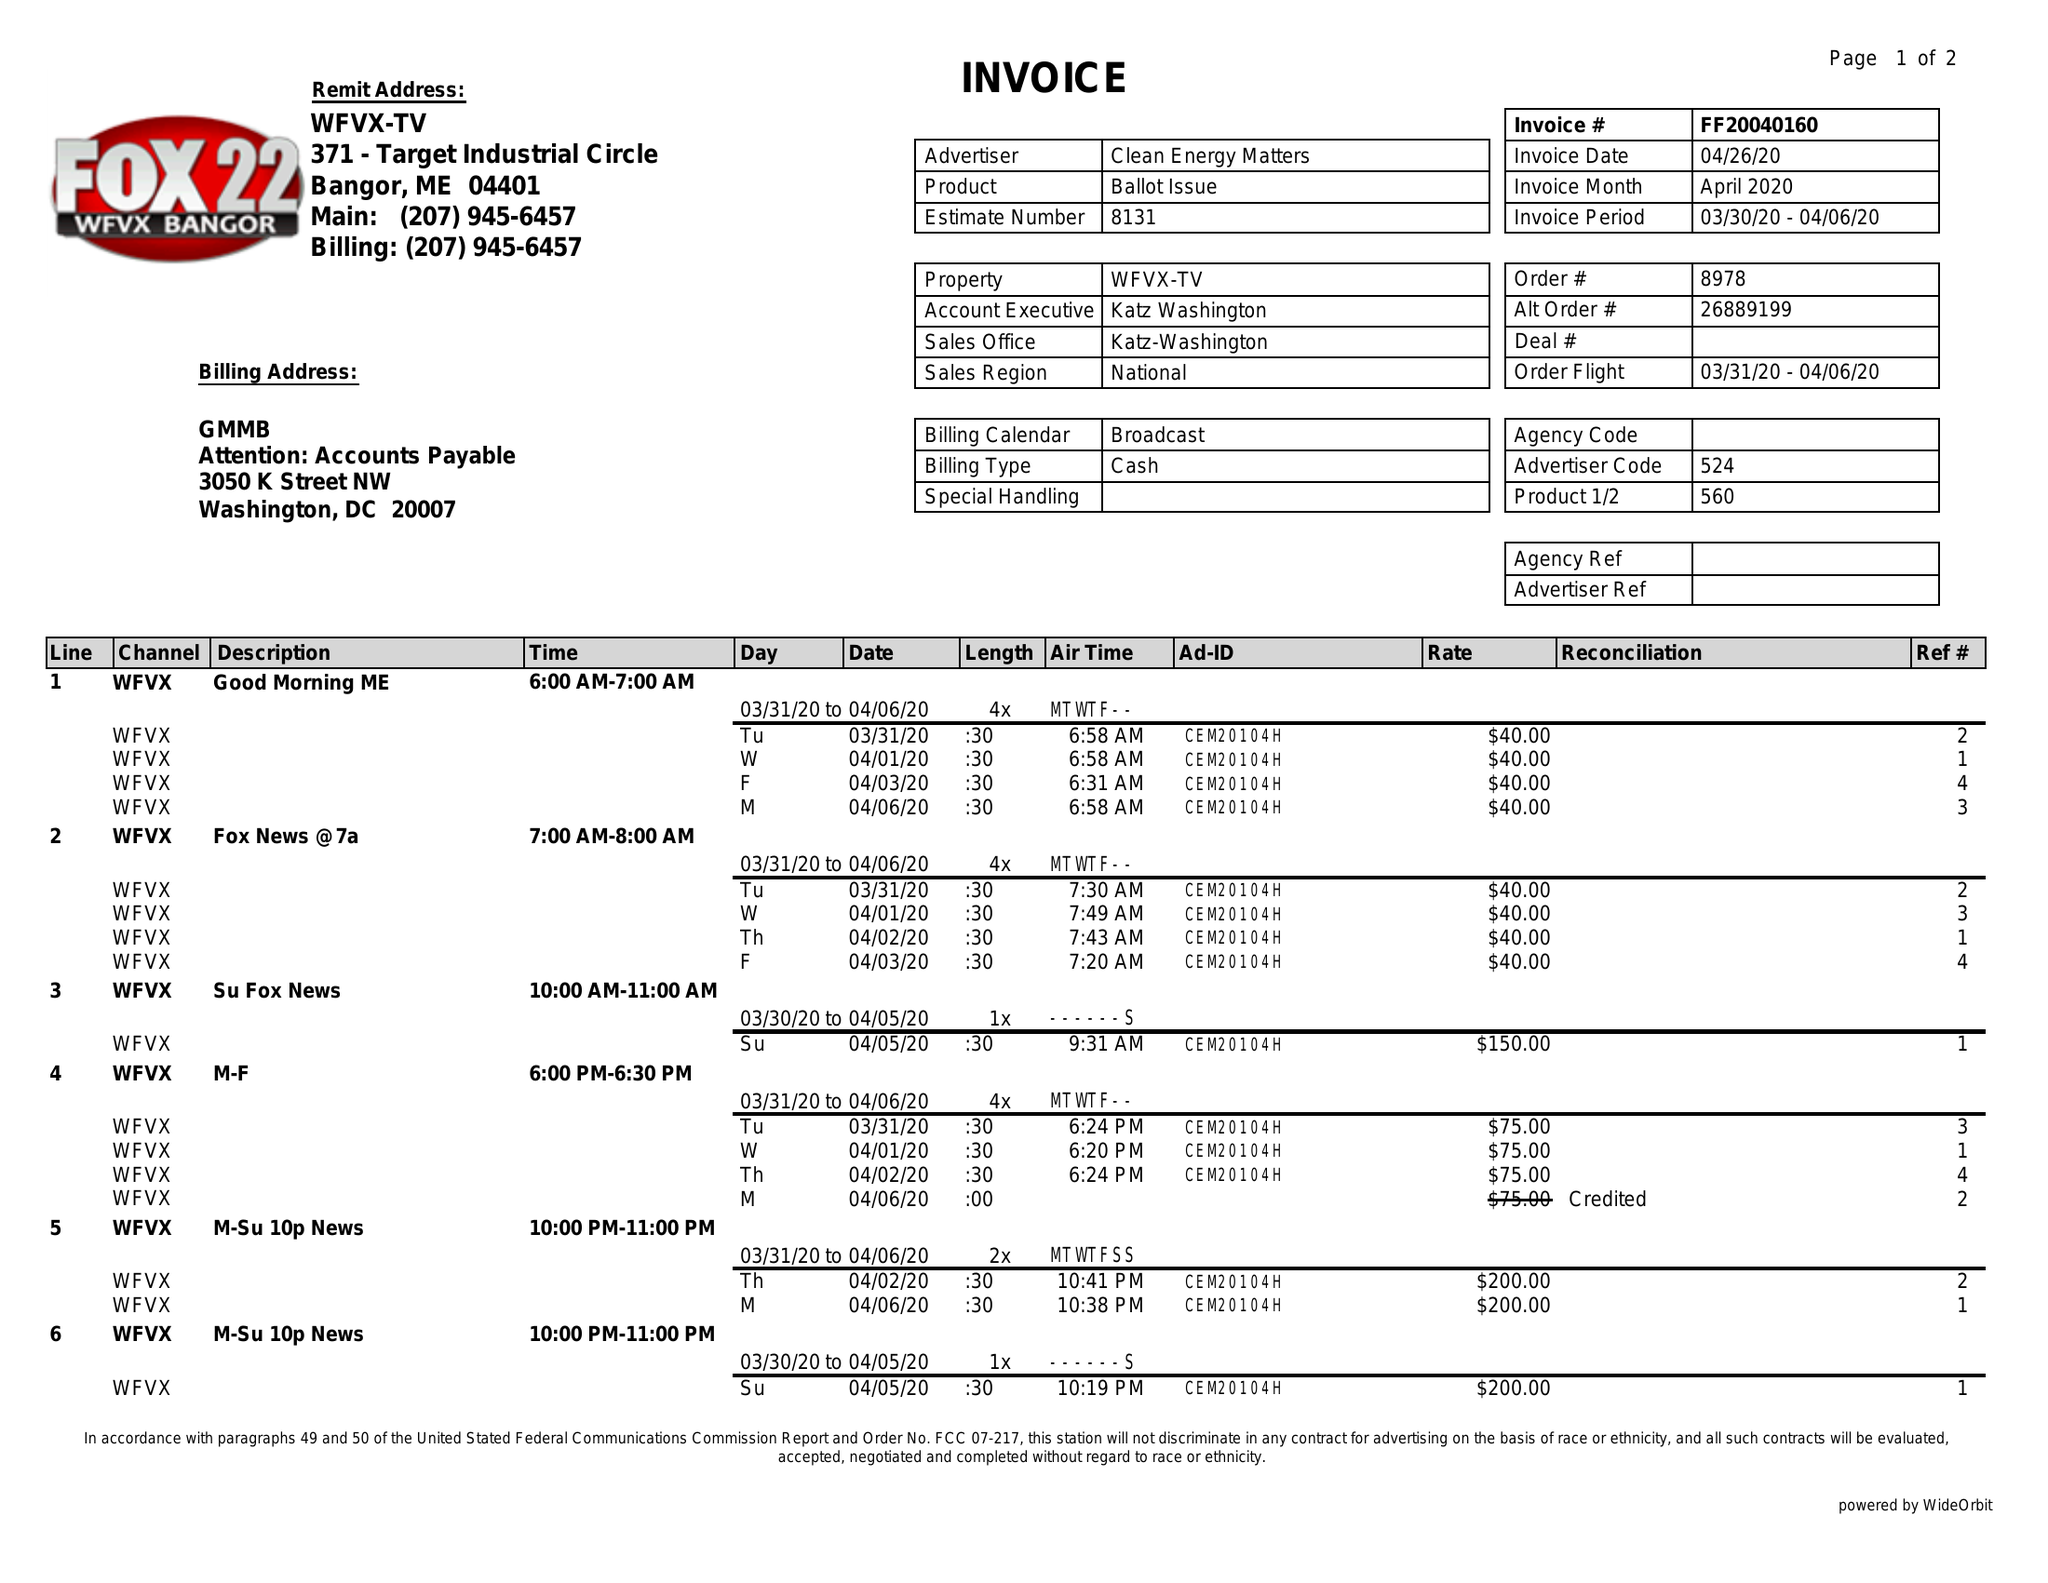What is the value for the advertiser?
Answer the question using a single word or phrase. CLEAN ENERGY MATTERS 